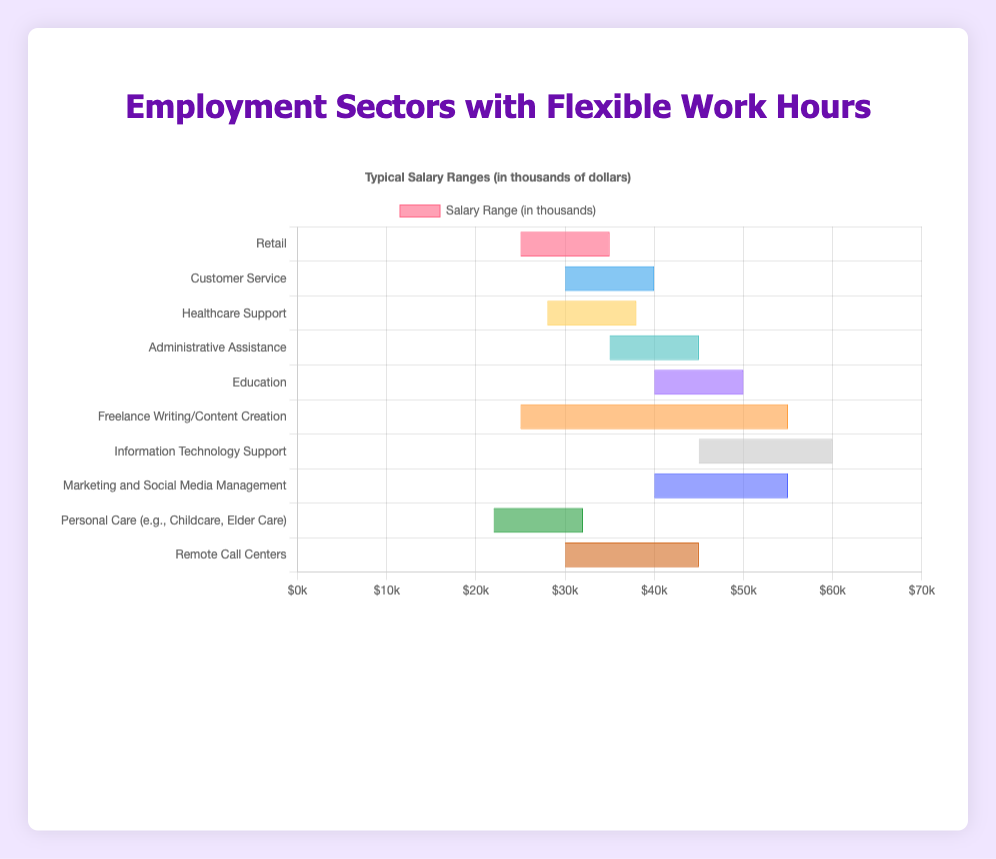What's the average minimum salary range across all sectors? To find the average, add up the minimum values of all the salary ranges and divide by the number of sectors: (25 + 30 + 28 + 35 + 40 + 25 + 45 + 40 + 22 + 30) / 10 = 320 / 10 = 32
Answer: 32 Which sector has the highest maximum salary range and what is it? The sector with the highest maximum salary is Information Technology Support with a maximum salary of $60,000.
Answer: Information Technology Support, $60,000 What's the difference between the highest and lowest minimum salary ranges? The highest minimum salary is $45,000 (Information Technology Support), and the lowest is $22,000 (Personal Care). The difference is 45 - 22 = $23,000
Answer: $23,000 Which sectors have a maximum salary range of at least $55,000? The sectors with at least $55,000 maximum salary are Freelance Writing/Content Creation ($55,000), Information Technology Support ($60,000), and Marketing and Social Media Management ($55,000).
Answer: Freelance Writing/Content Creation; Information Technology Support; Marketing and Social Media Management How many sectors have a typical salary range where the maximum is at least $50,000? Sectors where the maximum salary is at least $50,000 include Education, Freelance Writing/Content Creation, Information Technology Support, and Marketing and Social Media Management. There are 4 such sectors.
Answer: 4 Which sector has the smallest salary range and what is the range? Personal Care has the smallest salary range with a difference of $32,000 - $22,000 = $10,000
Answer: Personal Care, $10,000 What is the most common typical salary range (visually identify the color)? The most common typical salary range is in the $30,000 - $45,000 range, prominent in both Customer Service and Remote Call Centers, both of which share the color blue and brown.
Answer: Customer Service, Remote Call Centers In which sector does the minimum salary exceed $40,000? The sector where the minimum salary exceeds $40,000 is Information Technology Support.
Answer: Information Technology Support What is the salary range for the Administrative Assistance sector? The salary range for Administrative Assistance is $35,000 - $45,000 as indicated by the length of its bar in the figure.
Answer: $35,000 - $45,000 Comparing Healthcare Support and Customer Service, which sector has a higher maximum salary? Customer Service has a higher maximum salary ($40,000) compared to Healthcare Support ($38,000).
Answer: Customer Service 